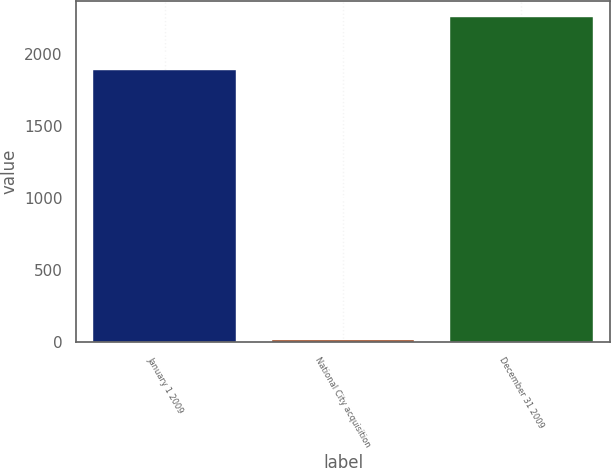Convert chart. <chart><loc_0><loc_0><loc_500><loc_500><bar_chart><fcel>January 1 2009<fcel>National City acquisition<fcel>December 31 2009<nl><fcel>1890<fcel>18<fcel>2259<nl></chart> 